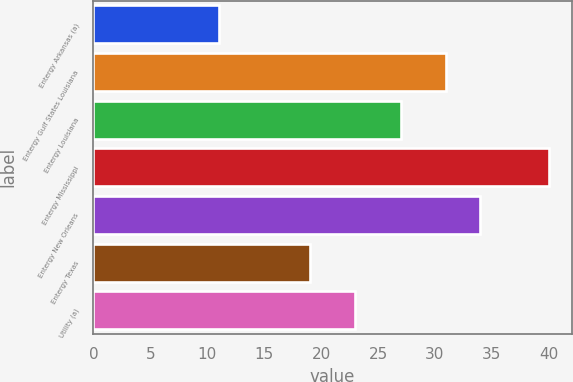Convert chart to OTSL. <chart><loc_0><loc_0><loc_500><loc_500><bar_chart><fcel>Entergy Arkansas (a)<fcel>Entergy Gulf States Louisiana<fcel>Entergy Louisiana<fcel>Entergy Mississippi<fcel>Entergy New Orleans<fcel>Entergy Texas<fcel>Utility (a)<nl><fcel>11<fcel>31<fcel>27<fcel>40<fcel>34<fcel>19<fcel>23<nl></chart> 